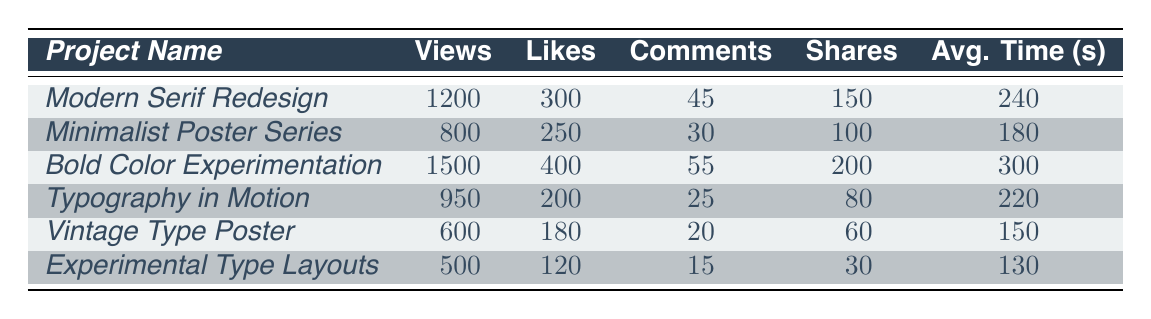What project had the highest number of views? Among all the projects, "Bold Color Experimentation" had the highest number of views at 1500.
Answer: Bold Color Experimentation What is the total number of likes across all typography projects? Adding all likes: 300 + 250 + 400 + 200 + 180 + 120 = 1450.
Answer: 1450 Which project received the least number of shares? The project with the least shares is "Experimental Type Layouts" with only 30 shares.
Answer: Experimental Type Layouts What is the average time spent on the "Minimalist Poster Series"? The average time spent on "Minimalist Poster Series" is directly listed in the table as 180 seconds.
Answer: 180 seconds How many more views did the "Modern Serif Redesign" have compared to the "Vintage Type Poster"? The difference in views is 1200 (Modern Serif Redesign) - 600 (Vintage Type Poster) = 600 views.
Answer: 600 views Which project had the highest engagement in terms of likes? "Bold Color Experimentation" received the highest likes at 400.
Answer: Bold Color Experimentation What is the median number of shares across the projects? The shares sorted are 30, 60, 80, 100, 150, 200. The median (average of the two middle values) is (80 + 100) / 2 = 90.
Answer: 90 shares Which project had the lowest average time spent? "Experimental Type Layouts" had the lowest average time spent at 130 seconds.
Answer: Experimental Type Layouts If we consider only the projects with over 1000 views, what is the average number of comments for these projects? The projects with over 1000 views are "Modern Serif Redesign" and "Bold Color Experimentation," with comments 45 and 55. Average is (45 + 55) / 2 = 50.
Answer: 50 comments How does the total engagement (views + likes + comments + shares) of "Typography in Motion" compare to "Vintage Type Poster"? Total for "Typography in Motion" = 950 + 200 + 25 + 80 = 1255. Total for "Vintage Type Poster" = 600 + 180 + 20 + 60 = 860. The difference is 1255 - 860 = 395.
Answer: 395 more views in Typography in Motion 